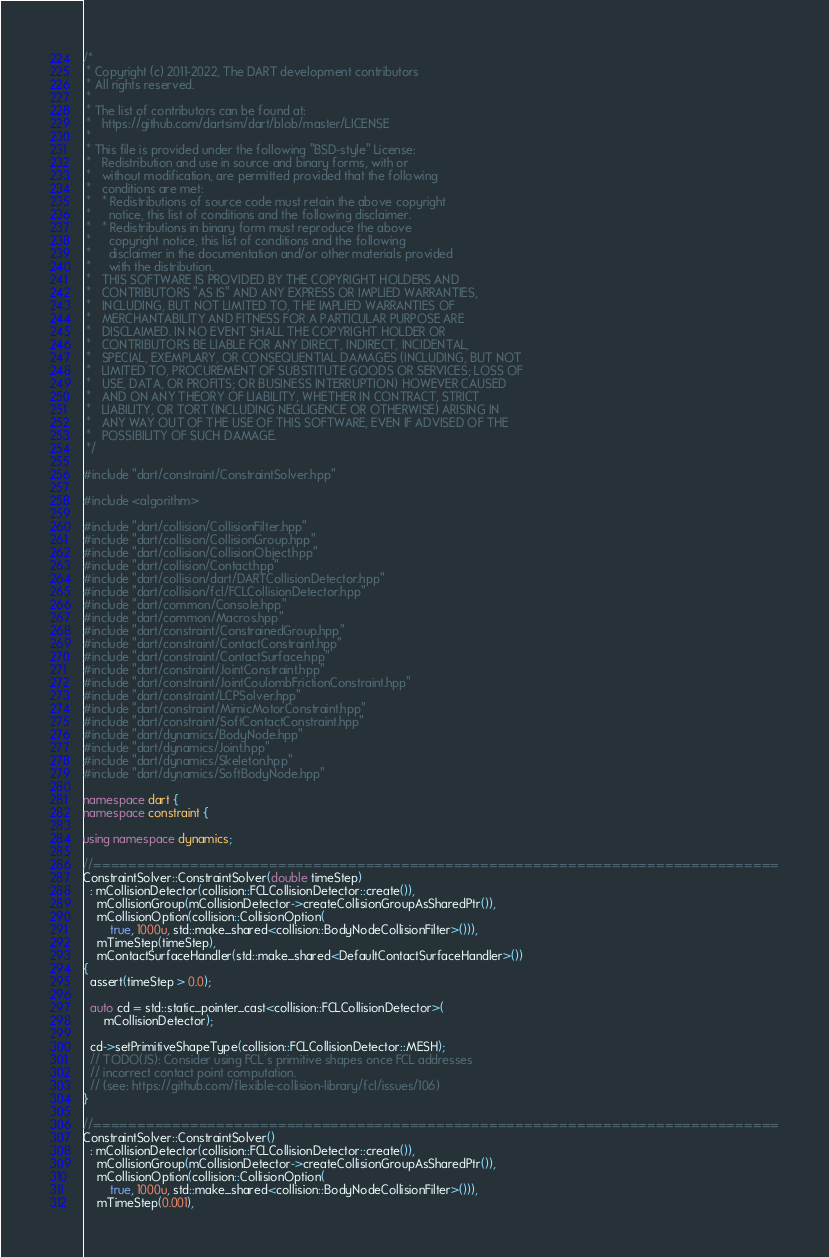Convert code to text. <code><loc_0><loc_0><loc_500><loc_500><_C++_>/*
 * Copyright (c) 2011-2022, The DART development contributors
 * All rights reserved.
 *
 * The list of contributors can be found at:
 *   https://github.com/dartsim/dart/blob/master/LICENSE
 *
 * This file is provided under the following "BSD-style" License:
 *   Redistribution and use in source and binary forms, with or
 *   without modification, are permitted provided that the following
 *   conditions are met:
 *   * Redistributions of source code must retain the above copyright
 *     notice, this list of conditions and the following disclaimer.
 *   * Redistributions in binary form must reproduce the above
 *     copyright notice, this list of conditions and the following
 *     disclaimer in the documentation and/or other materials provided
 *     with the distribution.
 *   THIS SOFTWARE IS PROVIDED BY THE COPYRIGHT HOLDERS AND
 *   CONTRIBUTORS "AS IS" AND ANY EXPRESS OR IMPLIED WARRANTIES,
 *   INCLUDING, BUT NOT LIMITED TO, THE IMPLIED WARRANTIES OF
 *   MERCHANTABILITY AND FITNESS FOR A PARTICULAR PURPOSE ARE
 *   DISCLAIMED. IN NO EVENT SHALL THE COPYRIGHT HOLDER OR
 *   CONTRIBUTORS BE LIABLE FOR ANY DIRECT, INDIRECT, INCIDENTAL,
 *   SPECIAL, EXEMPLARY, OR CONSEQUENTIAL DAMAGES (INCLUDING, BUT NOT
 *   LIMITED TO, PROCUREMENT OF SUBSTITUTE GOODS OR SERVICES; LOSS OF
 *   USE, DATA, OR PROFITS; OR BUSINESS INTERRUPTION) HOWEVER CAUSED
 *   AND ON ANY THEORY OF LIABILITY, WHETHER IN CONTRACT, STRICT
 *   LIABILITY, OR TORT (INCLUDING NEGLIGENCE OR OTHERWISE) ARISING IN
 *   ANY WAY OUT OF THE USE OF THIS SOFTWARE, EVEN IF ADVISED OF THE
 *   POSSIBILITY OF SUCH DAMAGE.
 */

#include "dart/constraint/ConstraintSolver.hpp"

#include <algorithm>

#include "dart/collision/CollisionFilter.hpp"
#include "dart/collision/CollisionGroup.hpp"
#include "dart/collision/CollisionObject.hpp"
#include "dart/collision/Contact.hpp"
#include "dart/collision/dart/DARTCollisionDetector.hpp"
#include "dart/collision/fcl/FCLCollisionDetector.hpp"
#include "dart/common/Console.hpp"
#include "dart/common/Macros.hpp"
#include "dart/constraint/ConstrainedGroup.hpp"
#include "dart/constraint/ContactConstraint.hpp"
#include "dart/constraint/ContactSurface.hpp"
#include "dart/constraint/JointConstraint.hpp"
#include "dart/constraint/JointCoulombFrictionConstraint.hpp"
#include "dart/constraint/LCPSolver.hpp"
#include "dart/constraint/MimicMotorConstraint.hpp"
#include "dart/constraint/SoftContactConstraint.hpp"
#include "dart/dynamics/BodyNode.hpp"
#include "dart/dynamics/Joint.hpp"
#include "dart/dynamics/Skeleton.hpp"
#include "dart/dynamics/SoftBodyNode.hpp"

namespace dart {
namespace constraint {

using namespace dynamics;

//==============================================================================
ConstraintSolver::ConstraintSolver(double timeStep)
  : mCollisionDetector(collision::FCLCollisionDetector::create()),
    mCollisionGroup(mCollisionDetector->createCollisionGroupAsSharedPtr()),
    mCollisionOption(collision::CollisionOption(
        true, 1000u, std::make_shared<collision::BodyNodeCollisionFilter>())),
    mTimeStep(timeStep),
    mContactSurfaceHandler(std::make_shared<DefaultContactSurfaceHandler>())
{
  assert(timeStep > 0.0);

  auto cd = std::static_pointer_cast<collision::FCLCollisionDetector>(
      mCollisionDetector);

  cd->setPrimitiveShapeType(collision::FCLCollisionDetector::MESH);
  // TODO(JS): Consider using FCL's primitive shapes once FCL addresses
  // incorrect contact point computation.
  // (see: https://github.com/flexible-collision-library/fcl/issues/106)
}

//==============================================================================
ConstraintSolver::ConstraintSolver()
  : mCollisionDetector(collision::FCLCollisionDetector::create()),
    mCollisionGroup(mCollisionDetector->createCollisionGroupAsSharedPtr()),
    mCollisionOption(collision::CollisionOption(
        true, 1000u, std::make_shared<collision::BodyNodeCollisionFilter>())),
    mTimeStep(0.001),</code> 